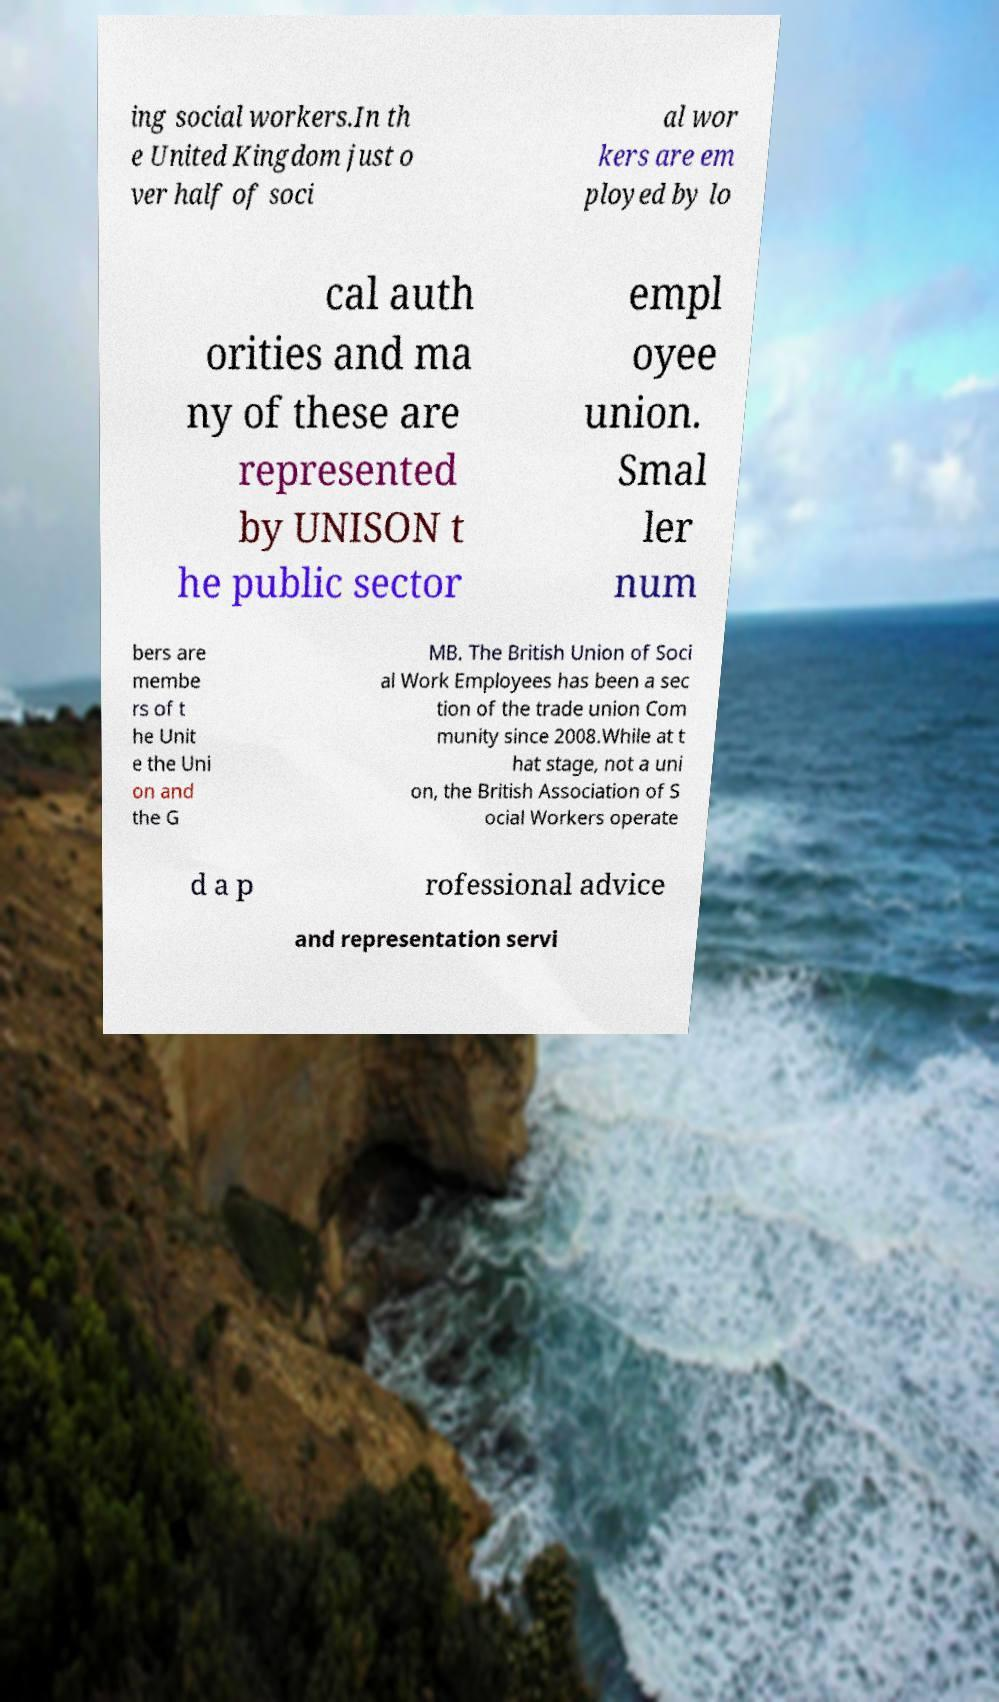I need the written content from this picture converted into text. Can you do that? ing social workers.In th e United Kingdom just o ver half of soci al wor kers are em ployed by lo cal auth orities and ma ny of these are represented by UNISON t he public sector empl oyee union. Smal ler num bers are membe rs of t he Unit e the Uni on and the G MB. The British Union of Soci al Work Employees has been a sec tion of the trade union Com munity since 2008.While at t hat stage, not a uni on, the British Association of S ocial Workers operate d a p rofessional advice and representation servi 